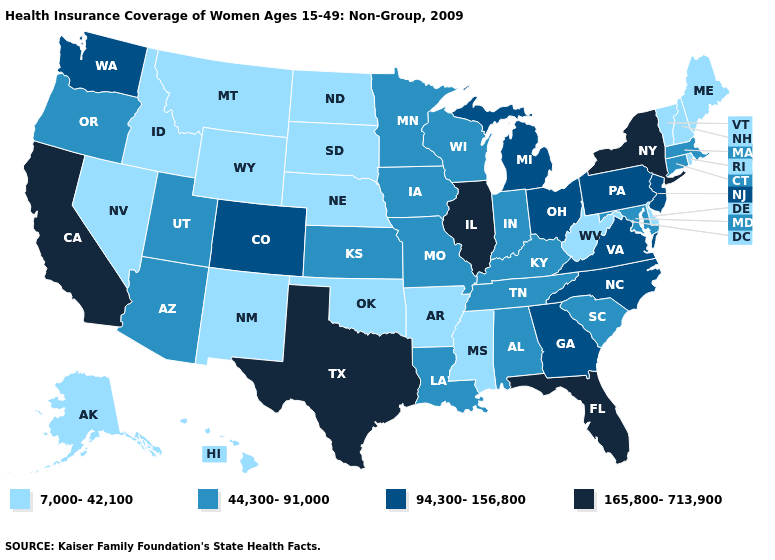Which states have the lowest value in the USA?
Write a very short answer. Alaska, Arkansas, Delaware, Hawaii, Idaho, Maine, Mississippi, Montana, Nebraska, Nevada, New Hampshire, New Mexico, North Dakota, Oklahoma, Rhode Island, South Dakota, Vermont, West Virginia, Wyoming. Does Florida have the highest value in the USA?
Quick response, please. Yes. Name the states that have a value in the range 44,300-91,000?
Quick response, please. Alabama, Arizona, Connecticut, Indiana, Iowa, Kansas, Kentucky, Louisiana, Maryland, Massachusetts, Minnesota, Missouri, Oregon, South Carolina, Tennessee, Utah, Wisconsin. What is the highest value in the USA?
Short answer required. 165,800-713,900. What is the lowest value in the USA?
Answer briefly. 7,000-42,100. Does Arkansas have a lower value than California?
Quick response, please. Yes. Among the states that border South Dakota , which have the highest value?
Concise answer only. Iowa, Minnesota. Does Ohio have the highest value in the MidWest?
Keep it brief. No. What is the value of Texas?
Concise answer only. 165,800-713,900. Which states hav the highest value in the West?
Concise answer only. California. What is the highest value in the MidWest ?
Give a very brief answer. 165,800-713,900. What is the lowest value in states that border Iowa?
Concise answer only. 7,000-42,100. Does Delaware have the highest value in the South?
Give a very brief answer. No. Does the map have missing data?
Write a very short answer. No. Does Arizona have the lowest value in the West?
Be succinct. No. 